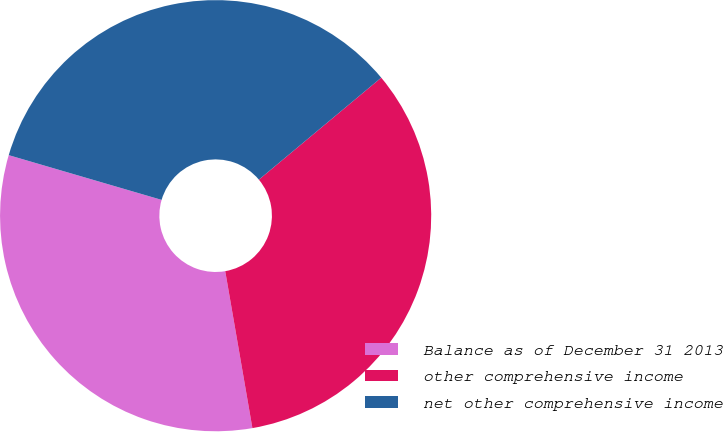Convert chart. <chart><loc_0><loc_0><loc_500><loc_500><pie_chart><fcel>Balance as of December 31 2013<fcel>other comprehensive income<fcel>net other comprehensive income<nl><fcel>32.26%<fcel>33.33%<fcel>34.41%<nl></chart> 